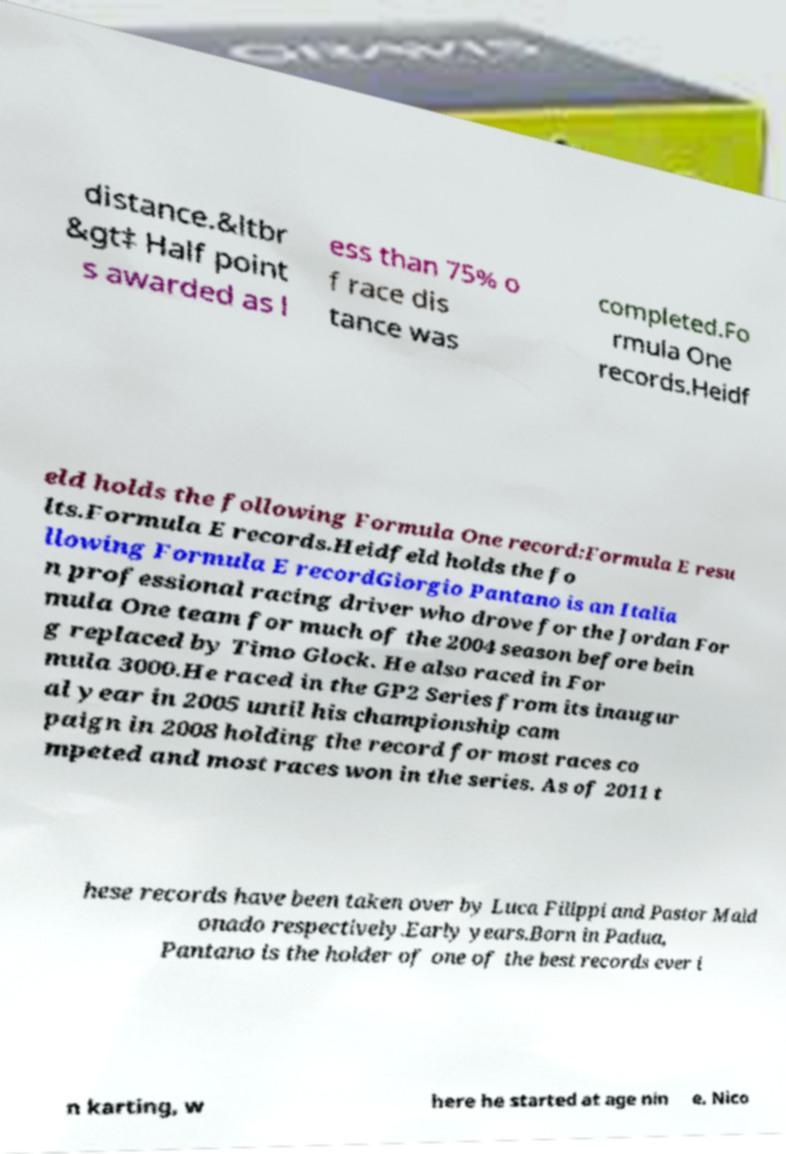Please read and relay the text visible in this image. What does it say? distance.&ltbr &gt‡ Half point s awarded as l ess than 75% o f race dis tance was completed.Fo rmula One records.Heidf eld holds the following Formula One record:Formula E resu lts.Formula E records.Heidfeld holds the fo llowing Formula E recordGiorgio Pantano is an Italia n professional racing driver who drove for the Jordan For mula One team for much of the 2004 season before bein g replaced by Timo Glock. He also raced in For mula 3000.He raced in the GP2 Series from its inaugur al year in 2005 until his championship cam paign in 2008 holding the record for most races co mpeted and most races won in the series. As of 2011 t hese records have been taken over by Luca Filippi and Pastor Mald onado respectively.Early years.Born in Padua, Pantano is the holder of one of the best records ever i n karting, w here he started at age nin e. Nico 